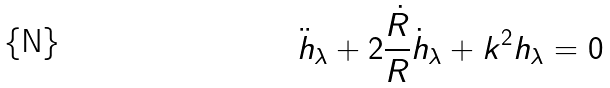Convert formula to latex. <formula><loc_0><loc_0><loc_500><loc_500>\ddot { h } _ { \lambda } + 2 { \frac { \dot { R } } { R } } \dot { h } _ { \lambda } + k ^ { 2 } h _ { \lambda } = 0</formula> 